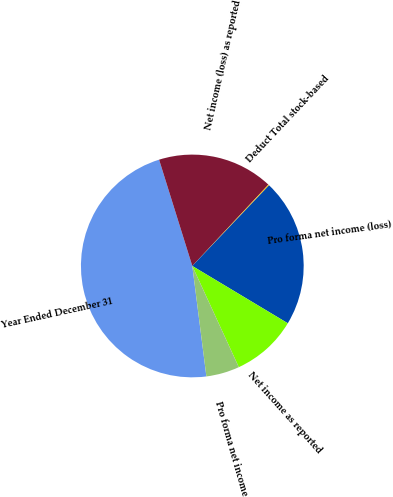Convert chart. <chart><loc_0><loc_0><loc_500><loc_500><pie_chart><fcel>Year Ended December 31<fcel>Net income (loss) as reported<fcel>Deduct Total stock-based<fcel>Pro forma net income (loss)<fcel>Net income as reported<fcel>Pro forma net income<nl><fcel>47.2%<fcel>16.79%<fcel>0.13%<fcel>21.5%<fcel>9.54%<fcel>4.84%<nl></chart> 